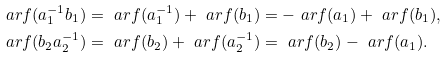Convert formula to latex. <formula><loc_0><loc_0><loc_500><loc_500>\ a r f ( a _ { 1 } ^ { - 1 } b _ { 1 } ) & = \ a r f ( a _ { 1 } ^ { - 1 } ) + \ a r f ( b _ { 1 } ) = - \ a r f ( a _ { 1 } ) + \ a r f ( b _ { 1 } ) , \\ \ a r f ( b _ { 2 } a _ { 2 } ^ { - 1 } ) & = \ a r f ( b _ { 2 } ) + \ a r f ( a _ { 2 } ^ { - 1 } ) = \ a r f ( b _ { 2 } ) - \ a r f ( a _ { 1 } ) .</formula> 